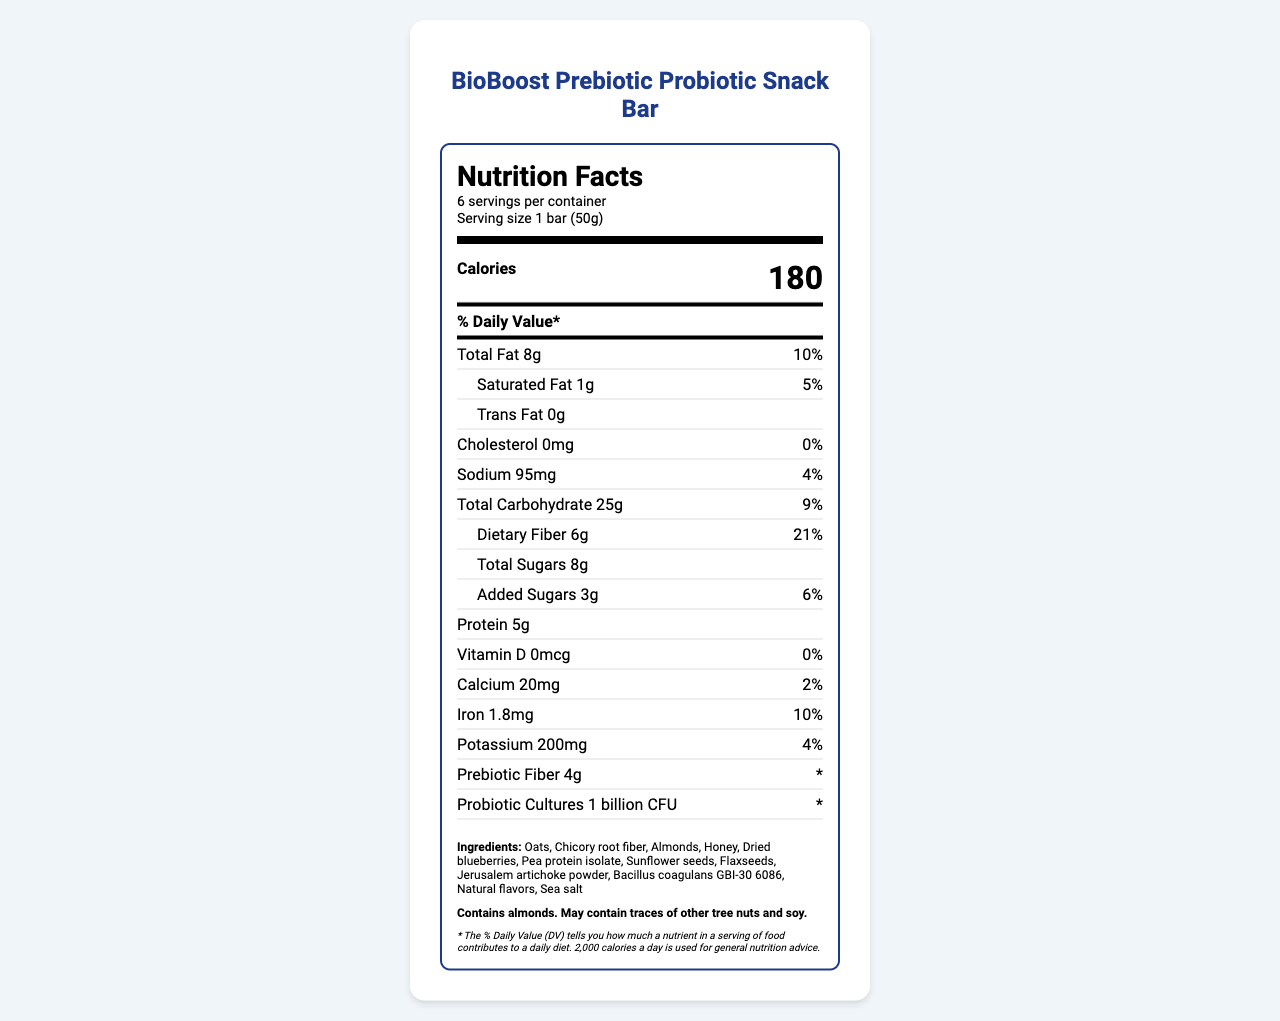what is the serving size of the BioBoost Prebiotic Probiotic Snack Bar? The serving size is clearly stated under the product name and nutritional information as "1 bar (50g)".
Answer: 1 bar (50g) how many calories are there per serving? The calories per serving are listed prominently in the nutrition label on the document.
Answer: 180 what is the percentage of daily value for dietary fiber in one serving? The dietary fiber's daily value percentage is provided in the nutritional section, next to the amount.
Answer: 21% does this product contain any saturated fat? If so, how much? The saturated fat content is listed under the total fat section, showing "1g" and a daily value of "5%".
Answer: Yes, 1g what probiotic strain is included in the BioBoost Snack Bar? The probiotic strain is mentioned in the list of ingredients towards the end of the document.
Answer: Bacillus coagulans GBI-30 6086 how many servings are there in a container? The number of servings per container is disclosed right under the title "Nutrition Facts".
Answer: 6 how many grams of added sugars does the snack bar contain? The amount of added sugars is provided in the carbohydrates section, showing "3g" and a daily value of "6%".
Answer: 3g how much total fat is there in one serving? The document lists total fat content under the nutrition label, noting it as "8g".
Answer: 8g what is the primary prebiotic content mentioned in the label? The document indicates these ingredients under the prebiotic effects section.
Answer: Chicory root fiber, Jerusalem artichoke powder which nutrient has the highest daily value percentage per serving, total fat or dietary fiber? Comparing the percentages, dietary fiber has 21% while total fat has 10%.
Answer: Dietary fiber which of the following ingredients is NOT listed in the snack bar? A. Oats B. Pea protein isolate C. Sugar D. Flaxseeds Sugar is not listed directly in the ingredients; however, honey is used as a sweetener.
Answer: C. Sugar the document states that the probiotics have a survival rate through the digestive system. Identify the probiotic survival rate model. A. Exponential growth model B. Probability and exponential decay models C. Linear regression model D. Logistic regression model The document mentions estimating probiotic survival rates using probability and exponential decay models.
Answer: B. Probability and exponential decay models does the BioBoost Prebiotic Probiotic Snack Bar contain any cholesterol? The document states "Cholesterol 0mg" next to "0% daily value".
Answer: No can the exact expected number of probiotics surviving through the stomach be determined from the visual information? The document discusses survival rates but does not provide specific calculations or detailed probability data.
Answer: Cannot be determined summarize the main points about the BioBoost Prebiotic Probiotic Snack Bar from the document. The summary covers the snack bar's nutritional composition, its purpose for gut health, details about its prebiotic and probiotic content, and its allergenic components.
Answer: The BioBoost Prebiotic Probiotic Snack Bar supports gut health and microbiome diversity. It provides 180 calories per serving with 8g of total fat, 25g of carbohydrates, and 5g of protein. It includes 1 billion CFU of Bacillus coagulans GBI-30 6086 and 4g of prebiotic fiber from ingredients like chicory root fiber and Jerusalem artichoke powder. The snack bar aims to enhance gut health with synbiotic effects and includes nutritional details along with allergen information listing almonds and possible traces of other tree nuts and soy. explain the role of each interdisciplinary connection listed in the document. Each interdisciplinary connection is linked with the gut health benefits and functional properties of the prebiotic and probiotic ingredients in the snack bar.
Answer: The document delineates connections such as biochemistry for analyzing prebiotic fibers, ecology for understanding the gut microbiome as an ecosystem, immunology for investigating probiotics on immunity, and metabolism for studying nutrient effects on blood glucose levels. 